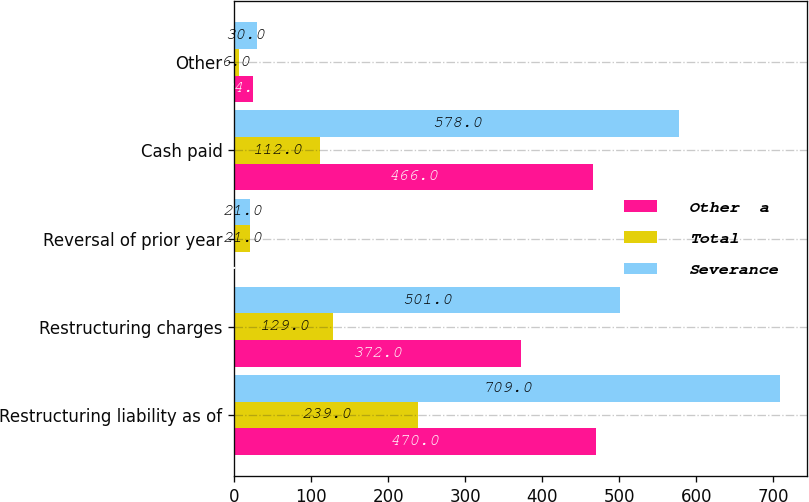Convert chart. <chart><loc_0><loc_0><loc_500><loc_500><stacked_bar_chart><ecel><fcel>Restructuring liability as of<fcel>Restructuring charges<fcel>Reversal of prior year<fcel>Cash paid<fcel>Other<nl><fcel>Other  a<fcel>470<fcel>372<fcel>0<fcel>466<fcel>24<nl><fcel>Total<fcel>239<fcel>129<fcel>21<fcel>112<fcel>6<nl><fcel>Severance<fcel>709<fcel>501<fcel>21<fcel>578<fcel>30<nl></chart> 